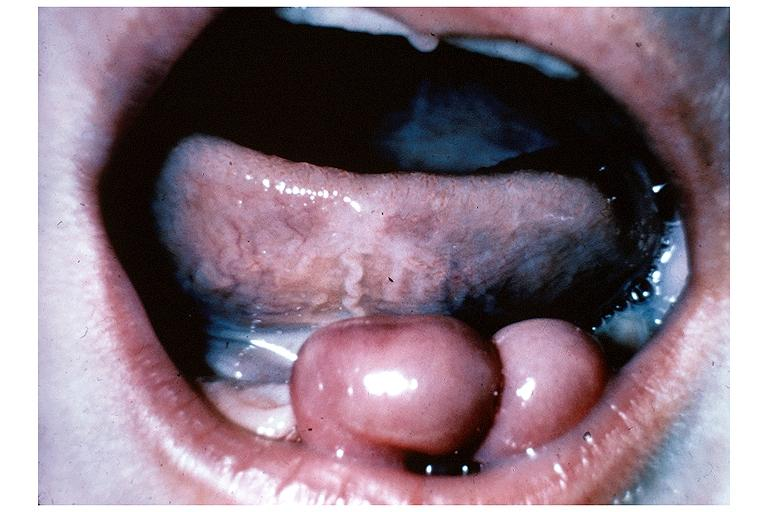where is this?
Answer the question using a single word or phrase. Oral 